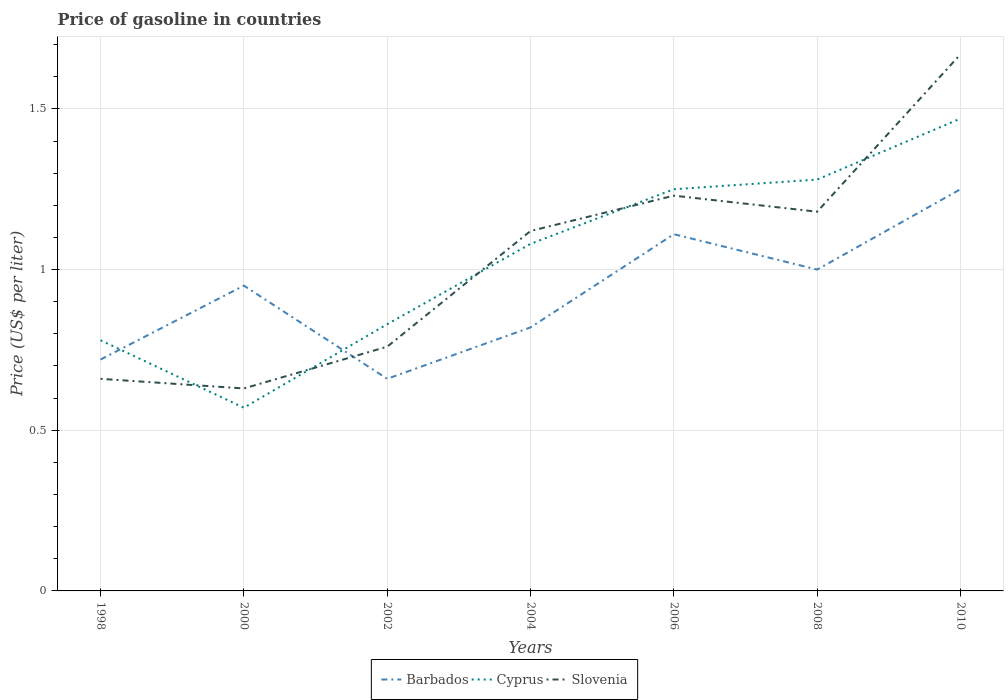Does the line corresponding to Cyprus intersect with the line corresponding to Barbados?
Give a very brief answer. Yes. Across all years, what is the maximum price of gasoline in Cyprus?
Give a very brief answer. 0.57. What is the difference between the highest and the second highest price of gasoline in Slovenia?
Make the answer very short. 1.04. What is the difference between the highest and the lowest price of gasoline in Cyprus?
Your answer should be very brief. 4. Is the price of gasoline in Cyprus strictly greater than the price of gasoline in Slovenia over the years?
Provide a succinct answer. No. How many years are there in the graph?
Provide a short and direct response. 7. How many legend labels are there?
Offer a terse response. 3. What is the title of the graph?
Offer a very short reply. Price of gasoline in countries. What is the label or title of the Y-axis?
Your answer should be very brief. Price (US$ per liter). What is the Price (US$ per liter) in Barbados in 1998?
Give a very brief answer. 0.72. What is the Price (US$ per liter) of Cyprus in 1998?
Your response must be concise. 0.78. What is the Price (US$ per liter) in Slovenia in 1998?
Make the answer very short. 0.66. What is the Price (US$ per liter) of Cyprus in 2000?
Your response must be concise. 0.57. What is the Price (US$ per liter) in Slovenia in 2000?
Your answer should be compact. 0.63. What is the Price (US$ per liter) of Barbados in 2002?
Your response must be concise. 0.66. What is the Price (US$ per liter) of Cyprus in 2002?
Make the answer very short. 0.83. What is the Price (US$ per liter) in Slovenia in 2002?
Give a very brief answer. 0.76. What is the Price (US$ per liter) in Barbados in 2004?
Offer a terse response. 0.82. What is the Price (US$ per liter) of Slovenia in 2004?
Your answer should be compact. 1.12. What is the Price (US$ per liter) in Barbados in 2006?
Your response must be concise. 1.11. What is the Price (US$ per liter) of Slovenia in 2006?
Offer a terse response. 1.23. What is the Price (US$ per liter) in Barbados in 2008?
Your response must be concise. 1. What is the Price (US$ per liter) of Cyprus in 2008?
Give a very brief answer. 1.28. What is the Price (US$ per liter) of Slovenia in 2008?
Provide a short and direct response. 1.18. What is the Price (US$ per liter) of Barbados in 2010?
Your answer should be compact. 1.25. What is the Price (US$ per liter) in Cyprus in 2010?
Your answer should be compact. 1.47. What is the Price (US$ per liter) of Slovenia in 2010?
Make the answer very short. 1.67. Across all years, what is the maximum Price (US$ per liter) in Barbados?
Make the answer very short. 1.25. Across all years, what is the maximum Price (US$ per liter) of Cyprus?
Your response must be concise. 1.47. Across all years, what is the maximum Price (US$ per liter) in Slovenia?
Provide a short and direct response. 1.67. Across all years, what is the minimum Price (US$ per liter) of Barbados?
Provide a succinct answer. 0.66. Across all years, what is the minimum Price (US$ per liter) in Cyprus?
Keep it short and to the point. 0.57. Across all years, what is the minimum Price (US$ per liter) in Slovenia?
Offer a very short reply. 0.63. What is the total Price (US$ per liter) in Barbados in the graph?
Provide a succinct answer. 6.51. What is the total Price (US$ per liter) of Cyprus in the graph?
Give a very brief answer. 7.26. What is the total Price (US$ per liter) in Slovenia in the graph?
Ensure brevity in your answer.  7.25. What is the difference between the Price (US$ per liter) in Barbados in 1998 and that in 2000?
Keep it short and to the point. -0.23. What is the difference between the Price (US$ per liter) of Cyprus in 1998 and that in 2000?
Your answer should be compact. 0.21. What is the difference between the Price (US$ per liter) of Barbados in 1998 and that in 2002?
Provide a succinct answer. 0.06. What is the difference between the Price (US$ per liter) of Barbados in 1998 and that in 2004?
Provide a succinct answer. -0.1. What is the difference between the Price (US$ per liter) of Cyprus in 1998 and that in 2004?
Your response must be concise. -0.3. What is the difference between the Price (US$ per liter) of Slovenia in 1998 and that in 2004?
Provide a succinct answer. -0.46. What is the difference between the Price (US$ per liter) in Barbados in 1998 and that in 2006?
Provide a succinct answer. -0.39. What is the difference between the Price (US$ per liter) of Cyprus in 1998 and that in 2006?
Make the answer very short. -0.47. What is the difference between the Price (US$ per liter) in Slovenia in 1998 and that in 2006?
Your answer should be very brief. -0.57. What is the difference between the Price (US$ per liter) in Barbados in 1998 and that in 2008?
Offer a terse response. -0.28. What is the difference between the Price (US$ per liter) of Cyprus in 1998 and that in 2008?
Keep it short and to the point. -0.5. What is the difference between the Price (US$ per liter) in Slovenia in 1998 and that in 2008?
Provide a short and direct response. -0.52. What is the difference between the Price (US$ per liter) of Barbados in 1998 and that in 2010?
Give a very brief answer. -0.53. What is the difference between the Price (US$ per liter) of Cyprus in 1998 and that in 2010?
Provide a succinct answer. -0.69. What is the difference between the Price (US$ per liter) of Slovenia in 1998 and that in 2010?
Keep it short and to the point. -1.01. What is the difference between the Price (US$ per liter) in Barbados in 2000 and that in 2002?
Provide a succinct answer. 0.29. What is the difference between the Price (US$ per liter) in Cyprus in 2000 and that in 2002?
Offer a terse response. -0.26. What is the difference between the Price (US$ per liter) of Slovenia in 2000 and that in 2002?
Provide a succinct answer. -0.13. What is the difference between the Price (US$ per liter) of Barbados in 2000 and that in 2004?
Give a very brief answer. 0.13. What is the difference between the Price (US$ per liter) of Cyprus in 2000 and that in 2004?
Provide a succinct answer. -0.51. What is the difference between the Price (US$ per liter) of Slovenia in 2000 and that in 2004?
Give a very brief answer. -0.49. What is the difference between the Price (US$ per liter) of Barbados in 2000 and that in 2006?
Your answer should be very brief. -0.16. What is the difference between the Price (US$ per liter) of Cyprus in 2000 and that in 2006?
Keep it short and to the point. -0.68. What is the difference between the Price (US$ per liter) of Barbados in 2000 and that in 2008?
Keep it short and to the point. -0.05. What is the difference between the Price (US$ per liter) of Cyprus in 2000 and that in 2008?
Provide a short and direct response. -0.71. What is the difference between the Price (US$ per liter) of Slovenia in 2000 and that in 2008?
Give a very brief answer. -0.55. What is the difference between the Price (US$ per liter) of Slovenia in 2000 and that in 2010?
Make the answer very short. -1.04. What is the difference between the Price (US$ per liter) in Barbados in 2002 and that in 2004?
Provide a short and direct response. -0.16. What is the difference between the Price (US$ per liter) of Slovenia in 2002 and that in 2004?
Your response must be concise. -0.36. What is the difference between the Price (US$ per liter) of Barbados in 2002 and that in 2006?
Your answer should be compact. -0.45. What is the difference between the Price (US$ per liter) of Cyprus in 2002 and that in 2006?
Your answer should be compact. -0.42. What is the difference between the Price (US$ per liter) in Slovenia in 2002 and that in 2006?
Keep it short and to the point. -0.47. What is the difference between the Price (US$ per liter) in Barbados in 2002 and that in 2008?
Your answer should be very brief. -0.34. What is the difference between the Price (US$ per liter) of Cyprus in 2002 and that in 2008?
Offer a very short reply. -0.45. What is the difference between the Price (US$ per liter) in Slovenia in 2002 and that in 2008?
Make the answer very short. -0.42. What is the difference between the Price (US$ per liter) of Barbados in 2002 and that in 2010?
Your answer should be compact. -0.59. What is the difference between the Price (US$ per liter) of Cyprus in 2002 and that in 2010?
Provide a succinct answer. -0.64. What is the difference between the Price (US$ per liter) in Slovenia in 2002 and that in 2010?
Give a very brief answer. -0.91. What is the difference between the Price (US$ per liter) of Barbados in 2004 and that in 2006?
Offer a terse response. -0.29. What is the difference between the Price (US$ per liter) in Cyprus in 2004 and that in 2006?
Provide a short and direct response. -0.17. What is the difference between the Price (US$ per liter) of Slovenia in 2004 and that in 2006?
Your answer should be compact. -0.11. What is the difference between the Price (US$ per liter) of Barbados in 2004 and that in 2008?
Your answer should be very brief. -0.18. What is the difference between the Price (US$ per liter) in Cyprus in 2004 and that in 2008?
Make the answer very short. -0.2. What is the difference between the Price (US$ per liter) of Slovenia in 2004 and that in 2008?
Offer a very short reply. -0.06. What is the difference between the Price (US$ per liter) in Barbados in 2004 and that in 2010?
Your answer should be compact. -0.43. What is the difference between the Price (US$ per liter) in Cyprus in 2004 and that in 2010?
Keep it short and to the point. -0.39. What is the difference between the Price (US$ per liter) of Slovenia in 2004 and that in 2010?
Give a very brief answer. -0.55. What is the difference between the Price (US$ per liter) in Barbados in 2006 and that in 2008?
Provide a short and direct response. 0.11. What is the difference between the Price (US$ per liter) of Cyprus in 2006 and that in 2008?
Your response must be concise. -0.03. What is the difference between the Price (US$ per liter) in Barbados in 2006 and that in 2010?
Provide a succinct answer. -0.14. What is the difference between the Price (US$ per liter) in Cyprus in 2006 and that in 2010?
Keep it short and to the point. -0.22. What is the difference between the Price (US$ per liter) in Slovenia in 2006 and that in 2010?
Your answer should be very brief. -0.44. What is the difference between the Price (US$ per liter) in Cyprus in 2008 and that in 2010?
Your response must be concise. -0.19. What is the difference between the Price (US$ per liter) of Slovenia in 2008 and that in 2010?
Ensure brevity in your answer.  -0.49. What is the difference between the Price (US$ per liter) of Barbados in 1998 and the Price (US$ per liter) of Cyprus in 2000?
Provide a short and direct response. 0.15. What is the difference between the Price (US$ per liter) in Barbados in 1998 and the Price (US$ per liter) in Slovenia in 2000?
Offer a very short reply. 0.09. What is the difference between the Price (US$ per liter) of Barbados in 1998 and the Price (US$ per liter) of Cyprus in 2002?
Offer a very short reply. -0.11. What is the difference between the Price (US$ per liter) of Barbados in 1998 and the Price (US$ per liter) of Slovenia in 2002?
Make the answer very short. -0.04. What is the difference between the Price (US$ per liter) in Barbados in 1998 and the Price (US$ per liter) in Cyprus in 2004?
Provide a short and direct response. -0.36. What is the difference between the Price (US$ per liter) of Cyprus in 1998 and the Price (US$ per liter) of Slovenia in 2004?
Your answer should be compact. -0.34. What is the difference between the Price (US$ per liter) of Barbados in 1998 and the Price (US$ per liter) of Cyprus in 2006?
Your response must be concise. -0.53. What is the difference between the Price (US$ per liter) in Barbados in 1998 and the Price (US$ per liter) in Slovenia in 2006?
Your answer should be compact. -0.51. What is the difference between the Price (US$ per liter) in Cyprus in 1998 and the Price (US$ per liter) in Slovenia in 2006?
Give a very brief answer. -0.45. What is the difference between the Price (US$ per liter) in Barbados in 1998 and the Price (US$ per liter) in Cyprus in 2008?
Give a very brief answer. -0.56. What is the difference between the Price (US$ per liter) in Barbados in 1998 and the Price (US$ per liter) in Slovenia in 2008?
Offer a very short reply. -0.46. What is the difference between the Price (US$ per liter) in Barbados in 1998 and the Price (US$ per liter) in Cyprus in 2010?
Keep it short and to the point. -0.75. What is the difference between the Price (US$ per liter) in Barbados in 1998 and the Price (US$ per liter) in Slovenia in 2010?
Provide a succinct answer. -0.95. What is the difference between the Price (US$ per liter) of Cyprus in 1998 and the Price (US$ per liter) of Slovenia in 2010?
Offer a terse response. -0.89. What is the difference between the Price (US$ per liter) of Barbados in 2000 and the Price (US$ per liter) of Cyprus in 2002?
Provide a succinct answer. 0.12. What is the difference between the Price (US$ per liter) in Barbados in 2000 and the Price (US$ per liter) in Slovenia in 2002?
Keep it short and to the point. 0.19. What is the difference between the Price (US$ per liter) of Cyprus in 2000 and the Price (US$ per liter) of Slovenia in 2002?
Offer a terse response. -0.19. What is the difference between the Price (US$ per liter) of Barbados in 2000 and the Price (US$ per liter) of Cyprus in 2004?
Your response must be concise. -0.13. What is the difference between the Price (US$ per liter) of Barbados in 2000 and the Price (US$ per liter) of Slovenia in 2004?
Your answer should be compact. -0.17. What is the difference between the Price (US$ per liter) in Cyprus in 2000 and the Price (US$ per liter) in Slovenia in 2004?
Provide a succinct answer. -0.55. What is the difference between the Price (US$ per liter) in Barbados in 2000 and the Price (US$ per liter) in Cyprus in 2006?
Ensure brevity in your answer.  -0.3. What is the difference between the Price (US$ per liter) in Barbados in 2000 and the Price (US$ per liter) in Slovenia in 2006?
Offer a very short reply. -0.28. What is the difference between the Price (US$ per liter) of Cyprus in 2000 and the Price (US$ per liter) of Slovenia in 2006?
Offer a very short reply. -0.66. What is the difference between the Price (US$ per liter) of Barbados in 2000 and the Price (US$ per liter) of Cyprus in 2008?
Your answer should be very brief. -0.33. What is the difference between the Price (US$ per liter) of Barbados in 2000 and the Price (US$ per liter) of Slovenia in 2008?
Provide a short and direct response. -0.23. What is the difference between the Price (US$ per liter) of Cyprus in 2000 and the Price (US$ per liter) of Slovenia in 2008?
Give a very brief answer. -0.61. What is the difference between the Price (US$ per liter) of Barbados in 2000 and the Price (US$ per liter) of Cyprus in 2010?
Give a very brief answer. -0.52. What is the difference between the Price (US$ per liter) in Barbados in 2000 and the Price (US$ per liter) in Slovenia in 2010?
Give a very brief answer. -0.72. What is the difference between the Price (US$ per liter) in Cyprus in 2000 and the Price (US$ per liter) in Slovenia in 2010?
Your answer should be very brief. -1.1. What is the difference between the Price (US$ per liter) in Barbados in 2002 and the Price (US$ per liter) in Cyprus in 2004?
Your answer should be very brief. -0.42. What is the difference between the Price (US$ per liter) of Barbados in 2002 and the Price (US$ per liter) of Slovenia in 2004?
Provide a short and direct response. -0.46. What is the difference between the Price (US$ per liter) of Cyprus in 2002 and the Price (US$ per liter) of Slovenia in 2004?
Provide a short and direct response. -0.29. What is the difference between the Price (US$ per liter) of Barbados in 2002 and the Price (US$ per liter) of Cyprus in 2006?
Ensure brevity in your answer.  -0.59. What is the difference between the Price (US$ per liter) in Barbados in 2002 and the Price (US$ per liter) in Slovenia in 2006?
Make the answer very short. -0.57. What is the difference between the Price (US$ per liter) of Barbados in 2002 and the Price (US$ per liter) of Cyprus in 2008?
Keep it short and to the point. -0.62. What is the difference between the Price (US$ per liter) in Barbados in 2002 and the Price (US$ per liter) in Slovenia in 2008?
Offer a terse response. -0.52. What is the difference between the Price (US$ per liter) in Cyprus in 2002 and the Price (US$ per liter) in Slovenia in 2008?
Offer a very short reply. -0.35. What is the difference between the Price (US$ per liter) in Barbados in 2002 and the Price (US$ per liter) in Cyprus in 2010?
Keep it short and to the point. -0.81. What is the difference between the Price (US$ per liter) in Barbados in 2002 and the Price (US$ per liter) in Slovenia in 2010?
Offer a very short reply. -1.01. What is the difference between the Price (US$ per liter) of Cyprus in 2002 and the Price (US$ per liter) of Slovenia in 2010?
Your answer should be compact. -0.84. What is the difference between the Price (US$ per liter) of Barbados in 2004 and the Price (US$ per liter) of Cyprus in 2006?
Provide a succinct answer. -0.43. What is the difference between the Price (US$ per liter) of Barbados in 2004 and the Price (US$ per liter) of Slovenia in 2006?
Provide a short and direct response. -0.41. What is the difference between the Price (US$ per liter) in Cyprus in 2004 and the Price (US$ per liter) in Slovenia in 2006?
Keep it short and to the point. -0.15. What is the difference between the Price (US$ per liter) in Barbados in 2004 and the Price (US$ per liter) in Cyprus in 2008?
Provide a short and direct response. -0.46. What is the difference between the Price (US$ per liter) in Barbados in 2004 and the Price (US$ per liter) in Slovenia in 2008?
Ensure brevity in your answer.  -0.36. What is the difference between the Price (US$ per liter) of Barbados in 2004 and the Price (US$ per liter) of Cyprus in 2010?
Your answer should be compact. -0.65. What is the difference between the Price (US$ per liter) in Barbados in 2004 and the Price (US$ per liter) in Slovenia in 2010?
Provide a short and direct response. -0.85. What is the difference between the Price (US$ per liter) of Cyprus in 2004 and the Price (US$ per liter) of Slovenia in 2010?
Keep it short and to the point. -0.59. What is the difference between the Price (US$ per liter) in Barbados in 2006 and the Price (US$ per liter) in Cyprus in 2008?
Ensure brevity in your answer.  -0.17. What is the difference between the Price (US$ per liter) of Barbados in 2006 and the Price (US$ per liter) of Slovenia in 2008?
Offer a very short reply. -0.07. What is the difference between the Price (US$ per liter) in Cyprus in 2006 and the Price (US$ per liter) in Slovenia in 2008?
Give a very brief answer. 0.07. What is the difference between the Price (US$ per liter) in Barbados in 2006 and the Price (US$ per liter) in Cyprus in 2010?
Offer a very short reply. -0.36. What is the difference between the Price (US$ per liter) in Barbados in 2006 and the Price (US$ per liter) in Slovenia in 2010?
Ensure brevity in your answer.  -0.56. What is the difference between the Price (US$ per liter) of Cyprus in 2006 and the Price (US$ per liter) of Slovenia in 2010?
Ensure brevity in your answer.  -0.42. What is the difference between the Price (US$ per liter) in Barbados in 2008 and the Price (US$ per liter) in Cyprus in 2010?
Offer a terse response. -0.47. What is the difference between the Price (US$ per liter) in Barbados in 2008 and the Price (US$ per liter) in Slovenia in 2010?
Make the answer very short. -0.67. What is the difference between the Price (US$ per liter) of Cyprus in 2008 and the Price (US$ per liter) of Slovenia in 2010?
Provide a succinct answer. -0.39. What is the average Price (US$ per liter) in Cyprus per year?
Give a very brief answer. 1.04. What is the average Price (US$ per liter) of Slovenia per year?
Your answer should be very brief. 1.04. In the year 1998, what is the difference between the Price (US$ per liter) in Barbados and Price (US$ per liter) in Cyprus?
Ensure brevity in your answer.  -0.06. In the year 1998, what is the difference between the Price (US$ per liter) of Barbados and Price (US$ per liter) of Slovenia?
Make the answer very short. 0.06. In the year 1998, what is the difference between the Price (US$ per liter) in Cyprus and Price (US$ per liter) in Slovenia?
Make the answer very short. 0.12. In the year 2000, what is the difference between the Price (US$ per liter) in Barbados and Price (US$ per liter) in Cyprus?
Provide a succinct answer. 0.38. In the year 2000, what is the difference between the Price (US$ per liter) of Barbados and Price (US$ per liter) of Slovenia?
Keep it short and to the point. 0.32. In the year 2000, what is the difference between the Price (US$ per liter) of Cyprus and Price (US$ per liter) of Slovenia?
Keep it short and to the point. -0.06. In the year 2002, what is the difference between the Price (US$ per liter) in Barbados and Price (US$ per liter) in Cyprus?
Offer a terse response. -0.17. In the year 2002, what is the difference between the Price (US$ per liter) of Cyprus and Price (US$ per liter) of Slovenia?
Offer a very short reply. 0.07. In the year 2004, what is the difference between the Price (US$ per liter) in Barbados and Price (US$ per liter) in Cyprus?
Provide a short and direct response. -0.26. In the year 2004, what is the difference between the Price (US$ per liter) in Barbados and Price (US$ per liter) in Slovenia?
Give a very brief answer. -0.3. In the year 2004, what is the difference between the Price (US$ per liter) of Cyprus and Price (US$ per liter) of Slovenia?
Offer a very short reply. -0.04. In the year 2006, what is the difference between the Price (US$ per liter) of Barbados and Price (US$ per liter) of Cyprus?
Make the answer very short. -0.14. In the year 2006, what is the difference between the Price (US$ per liter) of Barbados and Price (US$ per liter) of Slovenia?
Give a very brief answer. -0.12. In the year 2006, what is the difference between the Price (US$ per liter) of Cyprus and Price (US$ per liter) of Slovenia?
Your answer should be very brief. 0.02. In the year 2008, what is the difference between the Price (US$ per liter) of Barbados and Price (US$ per liter) of Cyprus?
Offer a terse response. -0.28. In the year 2008, what is the difference between the Price (US$ per liter) of Barbados and Price (US$ per liter) of Slovenia?
Your response must be concise. -0.18. In the year 2010, what is the difference between the Price (US$ per liter) in Barbados and Price (US$ per liter) in Cyprus?
Provide a short and direct response. -0.22. In the year 2010, what is the difference between the Price (US$ per liter) of Barbados and Price (US$ per liter) of Slovenia?
Keep it short and to the point. -0.42. In the year 2010, what is the difference between the Price (US$ per liter) of Cyprus and Price (US$ per liter) of Slovenia?
Your response must be concise. -0.2. What is the ratio of the Price (US$ per liter) in Barbados in 1998 to that in 2000?
Give a very brief answer. 0.76. What is the ratio of the Price (US$ per liter) of Cyprus in 1998 to that in 2000?
Provide a short and direct response. 1.37. What is the ratio of the Price (US$ per liter) in Slovenia in 1998 to that in 2000?
Keep it short and to the point. 1.05. What is the ratio of the Price (US$ per liter) in Barbados in 1998 to that in 2002?
Your response must be concise. 1.09. What is the ratio of the Price (US$ per liter) of Cyprus in 1998 to that in 2002?
Offer a very short reply. 0.94. What is the ratio of the Price (US$ per liter) in Slovenia in 1998 to that in 2002?
Your answer should be compact. 0.87. What is the ratio of the Price (US$ per liter) in Barbados in 1998 to that in 2004?
Make the answer very short. 0.88. What is the ratio of the Price (US$ per liter) of Cyprus in 1998 to that in 2004?
Offer a very short reply. 0.72. What is the ratio of the Price (US$ per liter) of Slovenia in 1998 to that in 2004?
Your answer should be very brief. 0.59. What is the ratio of the Price (US$ per liter) of Barbados in 1998 to that in 2006?
Provide a short and direct response. 0.65. What is the ratio of the Price (US$ per liter) of Cyprus in 1998 to that in 2006?
Offer a very short reply. 0.62. What is the ratio of the Price (US$ per liter) of Slovenia in 1998 to that in 2006?
Provide a short and direct response. 0.54. What is the ratio of the Price (US$ per liter) in Barbados in 1998 to that in 2008?
Your answer should be compact. 0.72. What is the ratio of the Price (US$ per liter) in Cyprus in 1998 to that in 2008?
Give a very brief answer. 0.61. What is the ratio of the Price (US$ per liter) of Slovenia in 1998 to that in 2008?
Your answer should be very brief. 0.56. What is the ratio of the Price (US$ per liter) of Barbados in 1998 to that in 2010?
Offer a very short reply. 0.58. What is the ratio of the Price (US$ per liter) in Cyprus in 1998 to that in 2010?
Keep it short and to the point. 0.53. What is the ratio of the Price (US$ per liter) of Slovenia in 1998 to that in 2010?
Make the answer very short. 0.4. What is the ratio of the Price (US$ per liter) of Barbados in 2000 to that in 2002?
Provide a short and direct response. 1.44. What is the ratio of the Price (US$ per liter) of Cyprus in 2000 to that in 2002?
Offer a very short reply. 0.69. What is the ratio of the Price (US$ per liter) in Slovenia in 2000 to that in 2002?
Make the answer very short. 0.83. What is the ratio of the Price (US$ per liter) of Barbados in 2000 to that in 2004?
Keep it short and to the point. 1.16. What is the ratio of the Price (US$ per liter) in Cyprus in 2000 to that in 2004?
Provide a succinct answer. 0.53. What is the ratio of the Price (US$ per liter) of Slovenia in 2000 to that in 2004?
Keep it short and to the point. 0.56. What is the ratio of the Price (US$ per liter) of Barbados in 2000 to that in 2006?
Your response must be concise. 0.86. What is the ratio of the Price (US$ per liter) of Cyprus in 2000 to that in 2006?
Provide a succinct answer. 0.46. What is the ratio of the Price (US$ per liter) in Slovenia in 2000 to that in 2006?
Offer a terse response. 0.51. What is the ratio of the Price (US$ per liter) of Barbados in 2000 to that in 2008?
Your response must be concise. 0.95. What is the ratio of the Price (US$ per liter) of Cyprus in 2000 to that in 2008?
Offer a very short reply. 0.45. What is the ratio of the Price (US$ per liter) of Slovenia in 2000 to that in 2008?
Offer a very short reply. 0.53. What is the ratio of the Price (US$ per liter) in Barbados in 2000 to that in 2010?
Keep it short and to the point. 0.76. What is the ratio of the Price (US$ per liter) of Cyprus in 2000 to that in 2010?
Ensure brevity in your answer.  0.39. What is the ratio of the Price (US$ per liter) in Slovenia in 2000 to that in 2010?
Your response must be concise. 0.38. What is the ratio of the Price (US$ per liter) of Barbados in 2002 to that in 2004?
Provide a succinct answer. 0.8. What is the ratio of the Price (US$ per liter) of Cyprus in 2002 to that in 2004?
Ensure brevity in your answer.  0.77. What is the ratio of the Price (US$ per liter) of Slovenia in 2002 to that in 2004?
Provide a short and direct response. 0.68. What is the ratio of the Price (US$ per liter) of Barbados in 2002 to that in 2006?
Ensure brevity in your answer.  0.59. What is the ratio of the Price (US$ per liter) in Cyprus in 2002 to that in 2006?
Your answer should be very brief. 0.66. What is the ratio of the Price (US$ per liter) in Slovenia in 2002 to that in 2006?
Your answer should be compact. 0.62. What is the ratio of the Price (US$ per liter) of Barbados in 2002 to that in 2008?
Your response must be concise. 0.66. What is the ratio of the Price (US$ per liter) in Cyprus in 2002 to that in 2008?
Your answer should be very brief. 0.65. What is the ratio of the Price (US$ per liter) of Slovenia in 2002 to that in 2008?
Offer a very short reply. 0.64. What is the ratio of the Price (US$ per liter) in Barbados in 2002 to that in 2010?
Your answer should be compact. 0.53. What is the ratio of the Price (US$ per liter) of Cyprus in 2002 to that in 2010?
Your response must be concise. 0.56. What is the ratio of the Price (US$ per liter) of Slovenia in 2002 to that in 2010?
Give a very brief answer. 0.46. What is the ratio of the Price (US$ per liter) in Barbados in 2004 to that in 2006?
Make the answer very short. 0.74. What is the ratio of the Price (US$ per liter) in Cyprus in 2004 to that in 2006?
Ensure brevity in your answer.  0.86. What is the ratio of the Price (US$ per liter) of Slovenia in 2004 to that in 2006?
Provide a succinct answer. 0.91. What is the ratio of the Price (US$ per liter) in Barbados in 2004 to that in 2008?
Your response must be concise. 0.82. What is the ratio of the Price (US$ per liter) of Cyprus in 2004 to that in 2008?
Provide a short and direct response. 0.84. What is the ratio of the Price (US$ per liter) of Slovenia in 2004 to that in 2008?
Your answer should be compact. 0.95. What is the ratio of the Price (US$ per liter) of Barbados in 2004 to that in 2010?
Your answer should be very brief. 0.66. What is the ratio of the Price (US$ per liter) of Cyprus in 2004 to that in 2010?
Offer a very short reply. 0.73. What is the ratio of the Price (US$ per liter) of Slovenia in 2004 to that in 2010?
Your response must be concise. 0.67. What is the ratio of the Price (US$ per liter) in Barbados in 2006 to that in 2008?
Your response must be concise. 1.11. What is the ratio of the Price (US$ per liter) in Cyprus in 2006 to that in 2008?
Provide a succinct answer. 0.98. What is the ratio of the Price (US$ per liter) in Slovenia in 2006 to that in 2008?
Your answer should be very brief. 1.04. What is the ratio of the Price (US$ per liter) of Barbados in 2006 to that in 2010?
Give a very brief answer. 0.89. What is the ratio of the Price (US$ per liter) of Cyprus in 2006 to that in 2010?
Your response must be concise. 0.85. What is the ratio of the Price (US$ per liter) of Slovenia in 2006 to that in 2010?
Offer a terse response. 0.74. What is the ratio of the Price (US$ per liter) of Cyprus in 2008 to that in 2010?
Your response must be concise. 0.87. What is the ratio of the Price (US$ per liter) in Slovenia in 2008 to that in 2010?
Make the answer very short. 0.71. What is the difference between the highest and the second highest Price (US$ per liter) of Barbados?
Provide a short and direct response. 0.14. What is the difference between the highest and the second highest Price (US$ per liter) of Cyprus?
Give a very brief answer. 0.19. What is the difference between the highest and the second highest Price (US$ per liter) in Slovenia?
Offer a terse response. 0.44. What is the difference between the highest and the lowest Price (US$ per liter) of Barbados?
Your answer should be very brief. 0.59. What is the difference between the highest and the lowest Price (US$ per liter) in Cyprus?
Ensure brevity in your answer.  0.9. What is the difference between the highest and the lowest Price (US$ per liter) of Slovenia?
Make the answer very short. 1.04. 